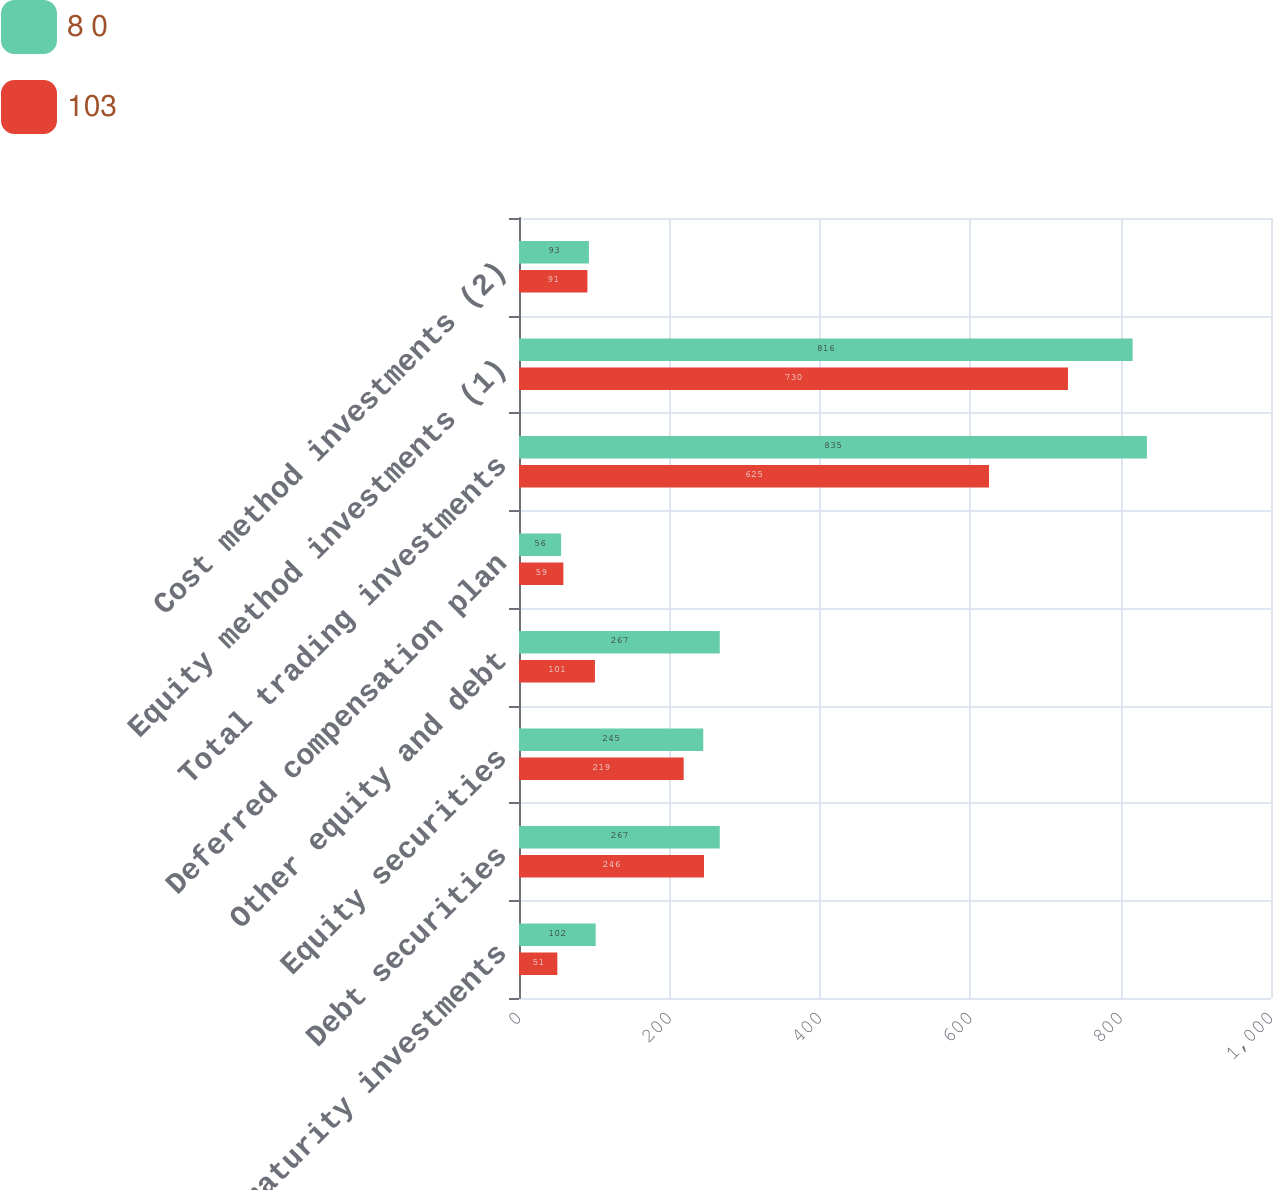Convert chart to OTSL. <chart><loc_0><loc_0><loc_500><loc_500><stacked_bar_chart><ecel><fcel>Held-to-maturity investments<fcel>Debt securities<fcel>Equity securities<fcel>Other equity and debt<fcel>Deferred compensation plan<fcel>Total trading investments<fcel>Equity method investments (1)<fcel>Cost method investments (2)<nl><fcel>8 0<fcel>102<fcel>267<fcel>245<fcel>267<fcel>56<fcel>835<fcel>816<fcel>93<nl><fcel>103<fcel>51<fcel>246<fcel>219<fcel>101<fcel>59<fcel>625<fcel>730<fcel>91<nl></chart> 